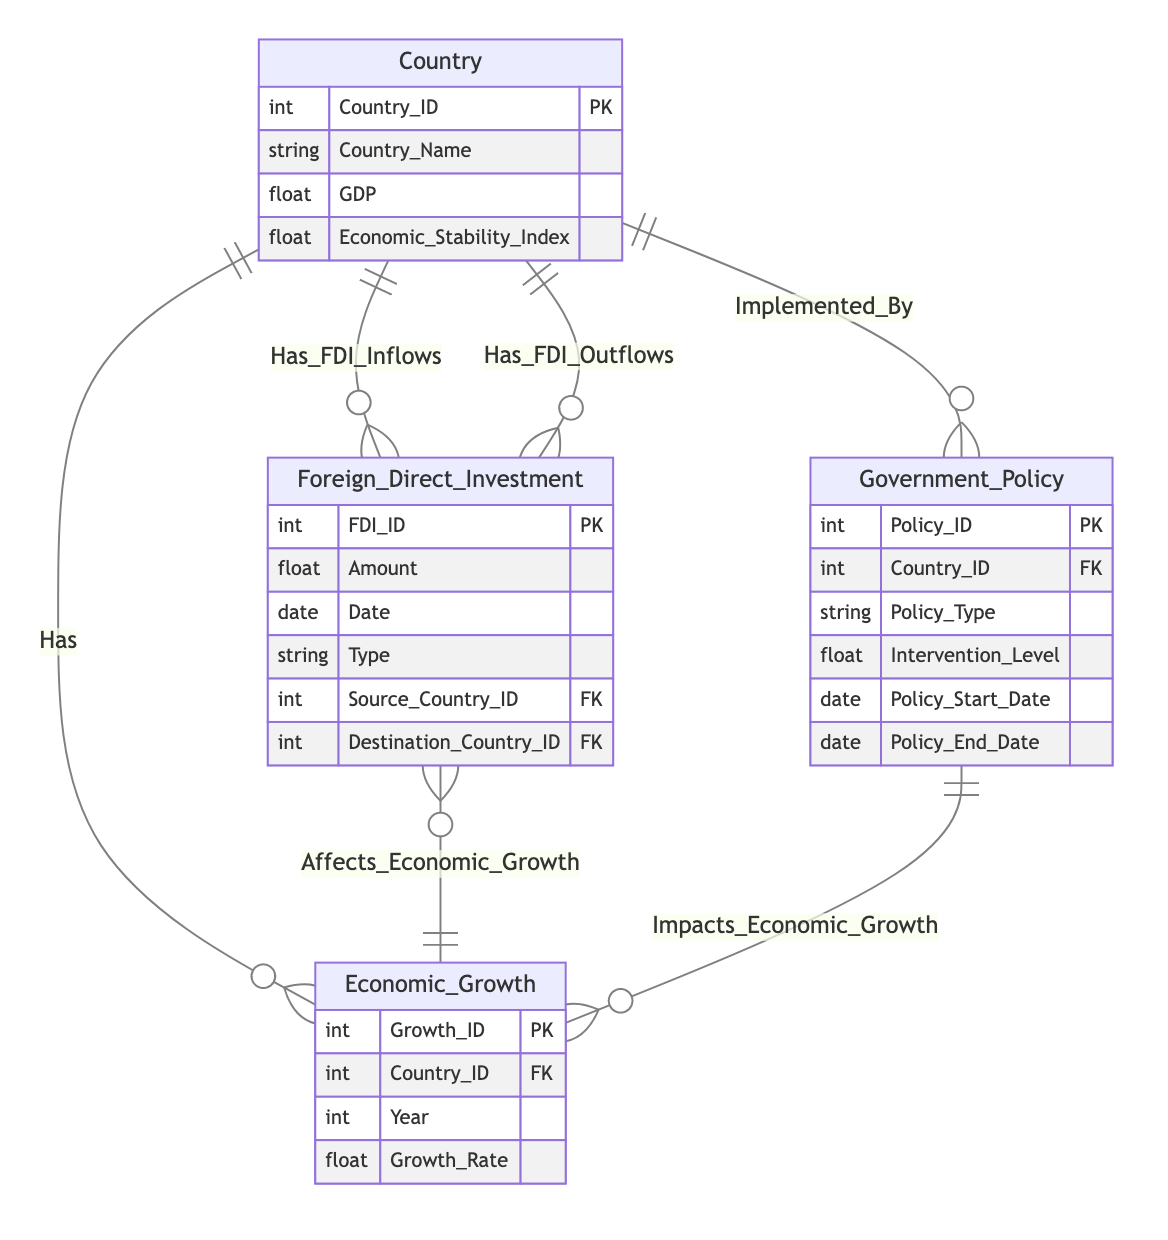What is the primary key of the Country entity? The primary key of the Country entity is identified in the diagram, which is indicated by the abbreviation "PK" alongside the attribute "Country_ID" within the Country entity section.
Answer: Country_ID How many entities are in the diagram? The diagram lists four entities: Country, Foreign Direct Investment, Economic Growth, and Government Policy, which can be counted directly from the entity section of the diagram.
Answer: Four What type of relationship exists between Country and Foreign Direct Investment for inflows? The type of relationship denoted in the diagram has a notation of "1:N" between Country and Foreign Direct Investment, which signifies that one country can have many FDI inflows.
Answer: One to Many Which entity directly affects Economic Growth? The Foreign Direct Investment entity shows a relationship marked "Affects_Economic_Growth," indicating that it has a direct impact on Economic Growth.
Answer: Foreign Direct Investment What relationship connects Government Policy and Economic Growth? The diagram designates a relationship titled "Impacts_Economic_Growth," indicating the connection between Government Policy and Economic Growth, which is a one-to-many relationship.
Answer: Impacts Economic Growth How many foreign keys does the Foreign Direct Investment entity have? Two foreign keys are listed in the Foreign Direct Investment entity: Source_Country_ID and Destination_Country_ID, which can be determined from the attributes of this entity as indicated in the diagram.
Answer: Two Which entity implements government policy? The Government Policy entity exhibits a relationship with Country, labeled as "Implemented_By," indicating that government policies are implemented by countries.
Answer: Country What is the relationship type between Government Policy and Country? The relationship type displayed between Government Policy and Country is noted as "N:1," indicating that many government policies can be implemented by one country.
Answer: Many to One What does the Economic Stability Index reflect? The Economic Stability Index is an attribute of the Country entity and reflects the economic stability of a country, as is evident from its attributes listed in the diagram.
Answer: Economic stability of a country 